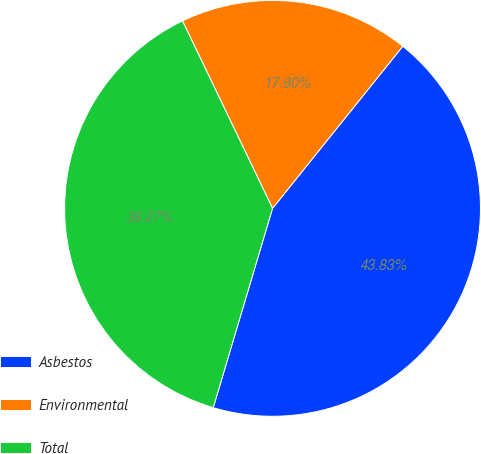Convert chart. <chart><loc_0><loc_0><loc_500><loc_500><pie_chart><fcel>Asbestos<fcel>Environmental<fcel>Total<nl><fcel>43.83%<fcel>17.9%<fcel>38.27%<nl></chart> 